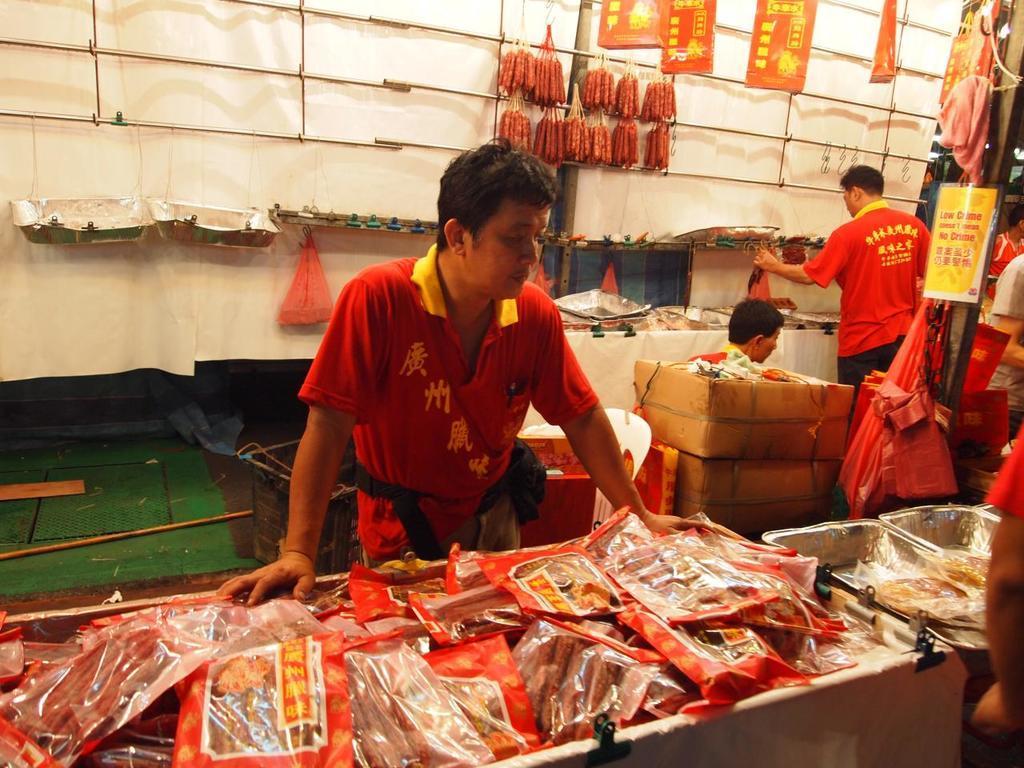Please provide a concise description of this image. In this image we can see some group of persons wearing red color dress selling some products which are red in color and in the background of the image there are some products hanged to the hanger, there are some cardboard boxes, boxes and a white color sheet. 